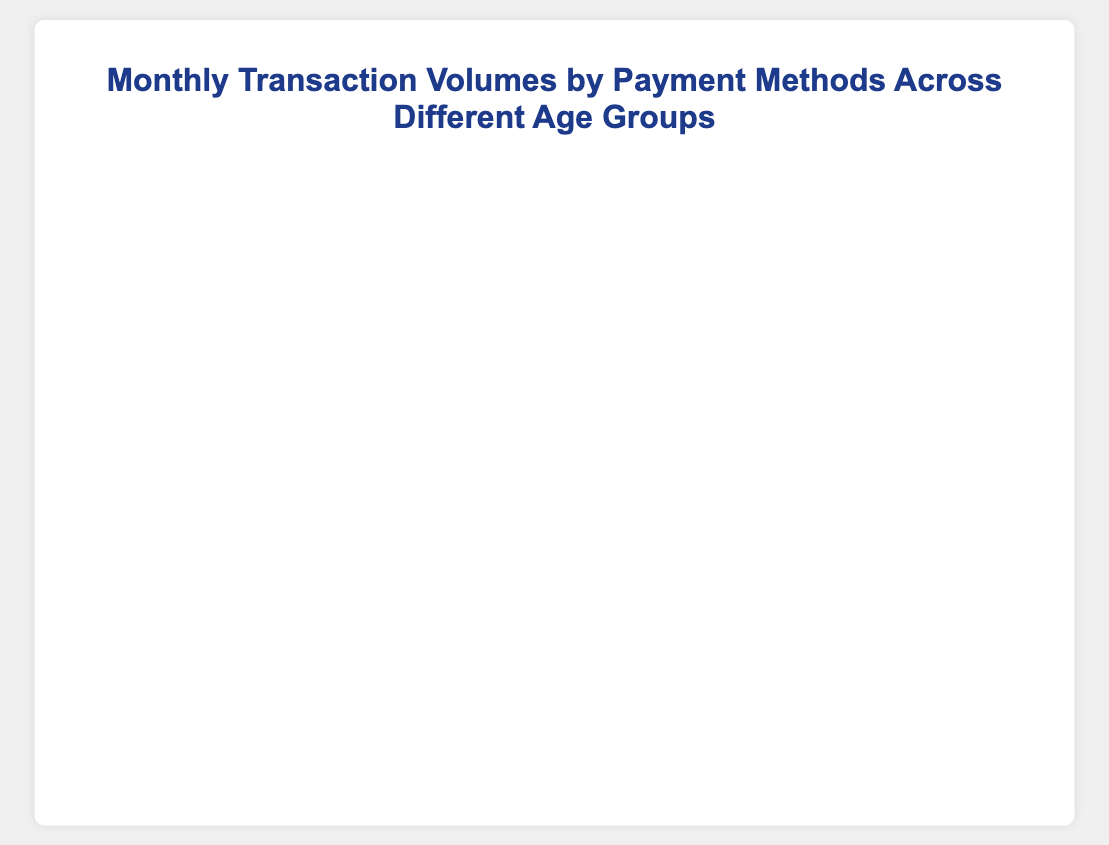How many total transactions are made by the "18-25" age group across all payment methods? Sum the transactions for the "18-25" age group across all payment methods: 300 (Credit Card) + 400 (Debit Card) + 200 (Mobile Payments) + 150 (Online Banking) + 100 (Cash). Then, 300 + 400 + 200 + 150 + 100 = 1150.
Answer: 1150 Which payment method has the highest number of transactions for the "26-35" age group? Compare the number of transactions for each payment method in the "26-35" age group: 500 (Credit Card), 600 (Debit Card), 350 (Mobile Payments), 400 (Online Banking), and 250 (Cash). The highest number is 600 (Debit Card).
Answer: Debit Card Among the "46-60" and "60+" age groups, which payment method shows the least usage, and what is the number of transactions? Compare the transactions in the "46-60" and "60+" age groups for each payment method: 
- "46-60": 350 (Credit Card), 500 (Debit Card), 200 (Mobile Payments), 400 (Online Banking), 350 (Cash)
- "60+": 200 (Credit Card), 300 (Debit Card), 100 (Mobile Payments), 200 (Online Banking), 200 (Cash). Mobile Payments show the lowest transactions with 200 (46-60) and 100 (60+).
Answer: Mobile Payments, 100 What is the average number of transactions made by the "36-45" age group across all payment methods? Calculate total transactions for "36-45" age group: 450 (Credit Card) + 550 (Debit Card) + 300 (Mobile Payments) + 450 (Online Banking) + 300 (Cash). Total: 450 + 550 + 300 + 450 + 300 = 2050. Number of payment methods: 5. Average = 2050/5 = 410.
Answer: 410 Which age group uses Credit Cards the most, and what is the number of transactions? Compare Credit Card transactions across age groups: 300 (18-25), 500 (26-35), 450 (36-45), 350 (46-60), 200 (60+). The highest number is 500 (26-35).
Answer: 26-35, 500 Do Debit Cards have more transactions than Mobile Payments for all age groups? Compare the number of transactions for Debit Cards and Mobile Payments across all age groups:
- "18-25": 400 (Debit Card) vs 200 (Mobile Payments)
- "26-35": 600 (Debit Card) vs 350 (Mobile Payments)
- "36-45": 550 (Debit Card) vs 300 (Mobile Payments)
- "46-60": 500 (Debit Card) vs 200 (Mobile Payments)
- "60+": 300 (Debit Card) vs 100 (Mobile Payments). Debit Cards have more transactions than Mobile Payments for all age groups.
Answer: Yes Which payment method has the lowest total transactions across all age groups, and what is the total number? Sum transactions for each payment method across all age groups:
- Credit Card: 300 + 500 + 450 + 350 + 200 = 1800
- Debit Card: 400 + 600 + 550 + 500 + 300 = 2350
- Mobile Payments: 200 + 350 + 300 + 200 + 100 = 1150
- Online Banking: 150 + 400 + 450 + 400 + 200 = 1600
- Cash: 100 + 250 + 300 + 350 + 200 = 1200. The lowest total is for Mobile Payments: 1150 transactions.
Answer: Mobile Payments, 1150 How many more transactions are made using Debit Cards than Cash for the "46-60" age group? Debit Card transactions for "46-60": 500, Cash transactions for "46-60": 350. Difference is 500 - 350 = 150.
Answer: 150 